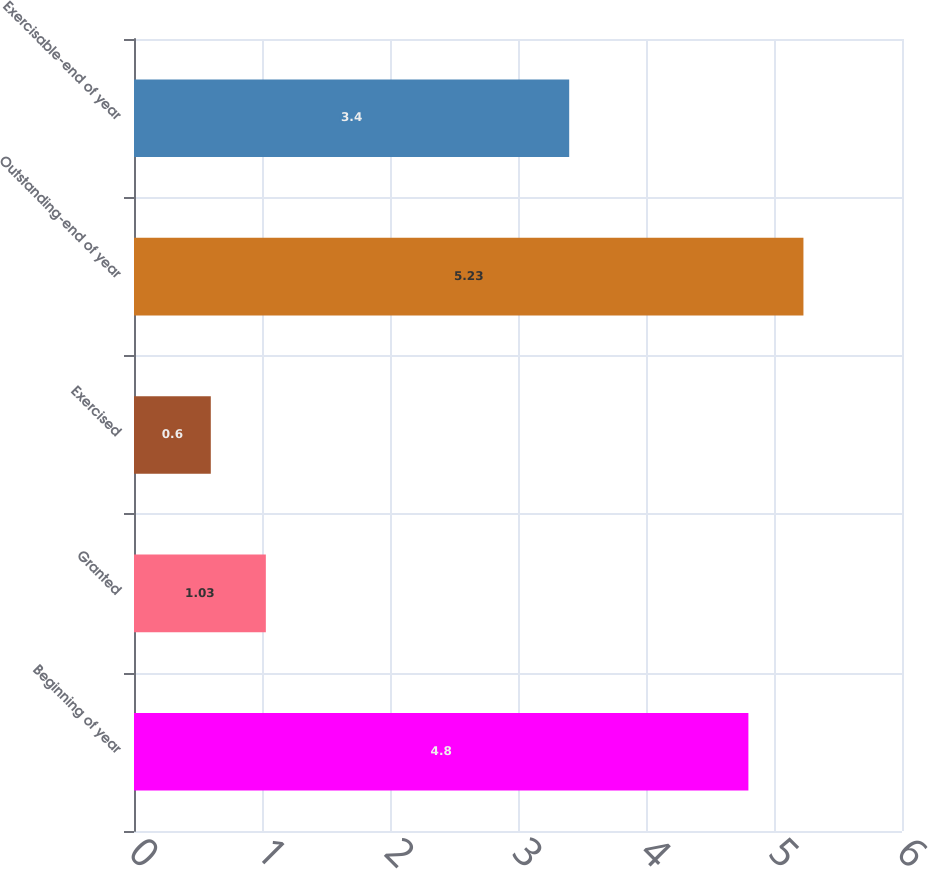Convert chart. <chart><loc_0><loc_0><loc_500><loc_500><bar_chart><fcel>Beginning of year<fcel>Granted<fcel>Exercised<fcel>Outstanding-end of year<fcel>Exercisable-end of year<nl><fcel>4.8<fcel>1.03<fcel>0.6<fcel>5.23<fcel>3.4<nl></chart> 